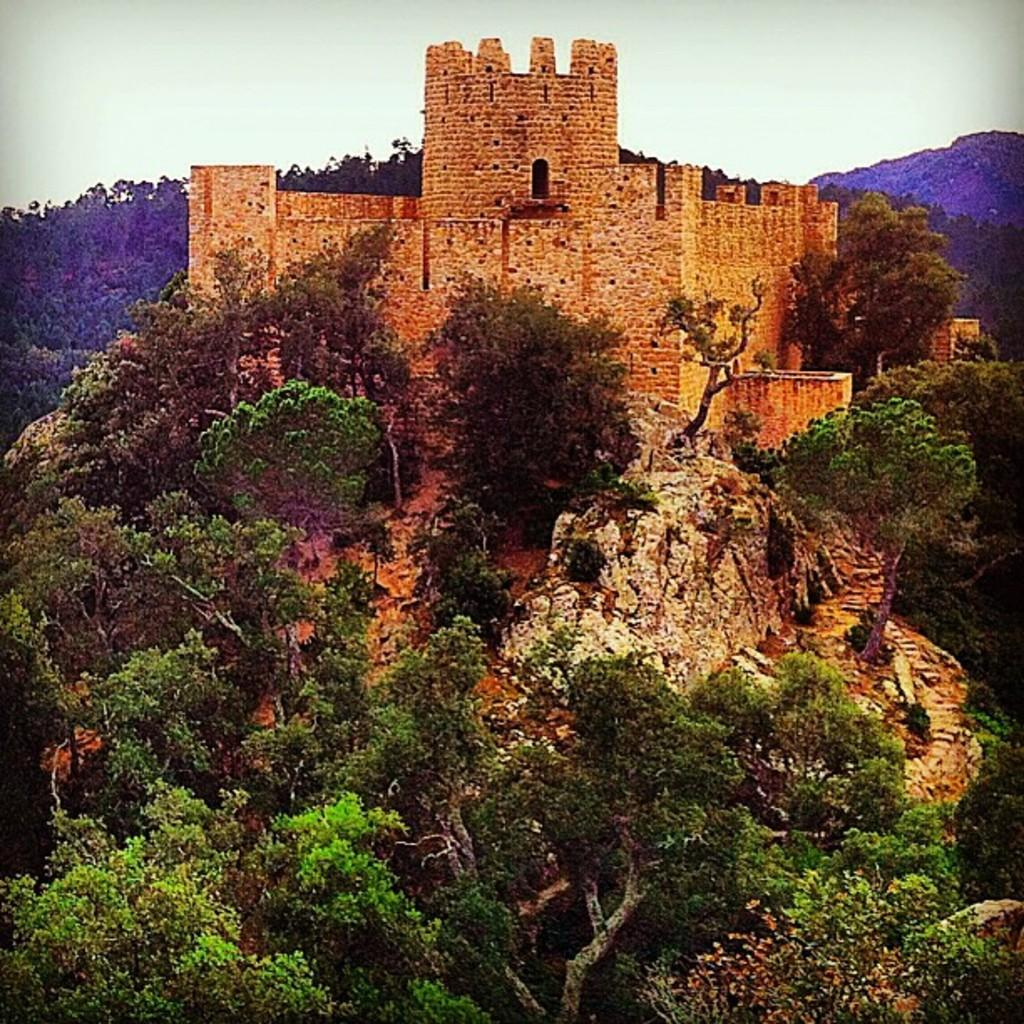What can be seen at the bottom of the picture? There are trees and rocks at the bottom of the picture. What structure is located behind the trees and rocks? There is a fort behind the trees and rocks. What type of natural features are visible in the background of the image? There are trees and hills in the background of the image. What is visible at the top of the picture? The sky is visible at the top of the picture. How many kittens are playing with balls on the fort in the image? There are no kittens or balls present in the image; it features a fort, trees, rocks, and a sky. Are there any trucks visible in the image? There are no trucks present in the image. 